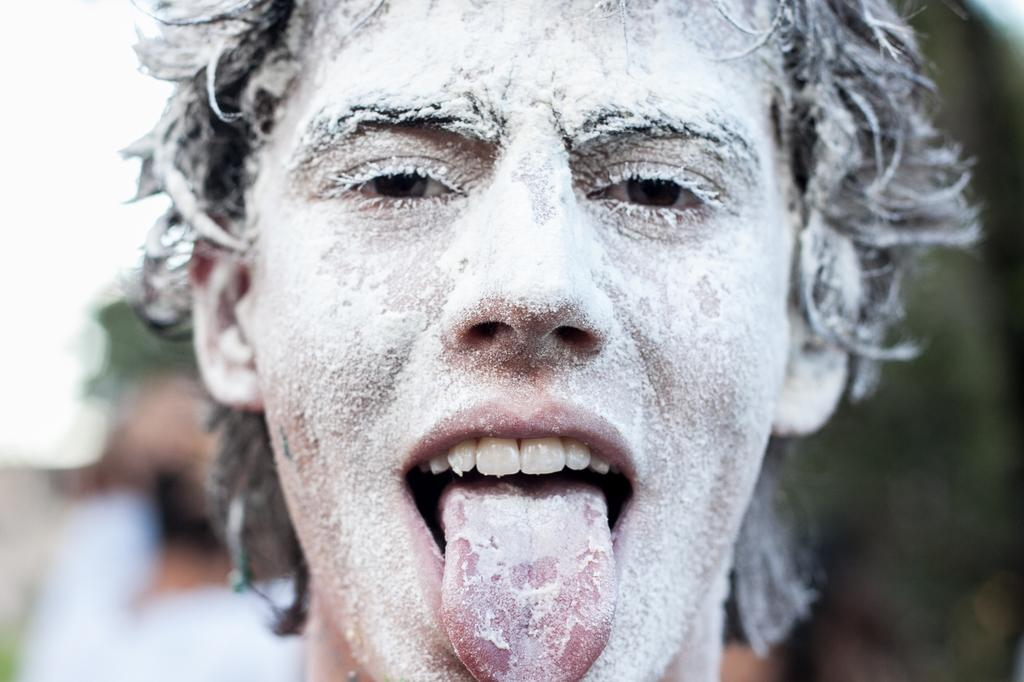What is the main subject of the image? There is a person in the image. How is the person's face in the image? The person's face is covered with white color powder. Can you describe the background of the image? The background of the image is blurred. How many chickens are visible in the image? There are no chickens present in the image. Is the person wearing stockings in the image? The provided facts do not mention anything about the person's legs or stockings, so we cannot determine if they are wearing stockings from the image. Can you tell me how many times the person sneezed in the image? There is no indication of the person sneezing in the image, so we cannot determine how many times they sneezed. 